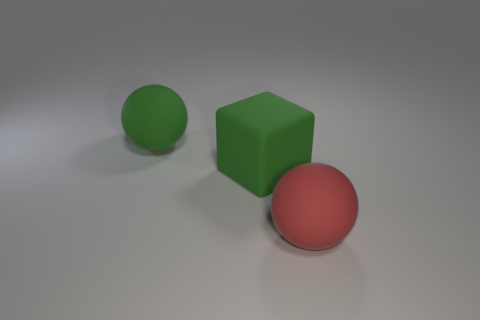There is a object that is behind the red matte object and on the right side of the green ball; what color is it?
Offer a terse response. Green. Is the large sphere that is on the right side of the big green matte sphere made of the same material as the big green ball?
Your answer should be very brief. Yes. Is the number of large objects in front of the large green sphere less than the number of large rubber blocks?
Make the answer very short. No. Is there a purple ball made of the same material as the big cube?
Give a very brief answer. No. There is a green cube; is its size the same as the rubber ball left of the red rubber sphere?
Offer a very short reply. Yes. Are there any small shiny objects that have the same color as the big block?
Keep it short and to the point. No. Is the material of the green ball the same as the green cube?
Give a very brief answer. Yes. There is a red ball; what number of green matte objects are to the left of it?
Make the answer very short. 2. There is a thing that is left of the big red thing and on the right side of the big green ball; what material is it?
Offer a very short reply. Rubber. What number of other matte cubes are the same size as the green cube?
Your response must be concise. 0. 